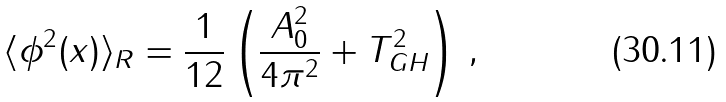Convert formula to latex. <formula><loc_0><loc_0><loc_500><loc_500>\langle \phi ^ { 2 } ( x ) \rangle _ { R } = \frac { 1 } { 1 2 } \left ( \frac { A _ { 0 } ^ { 2 } } { 4 \pi ^ { 2 } } + T ^ { 2 } _ { G H } \right ) \, ,</formula> 